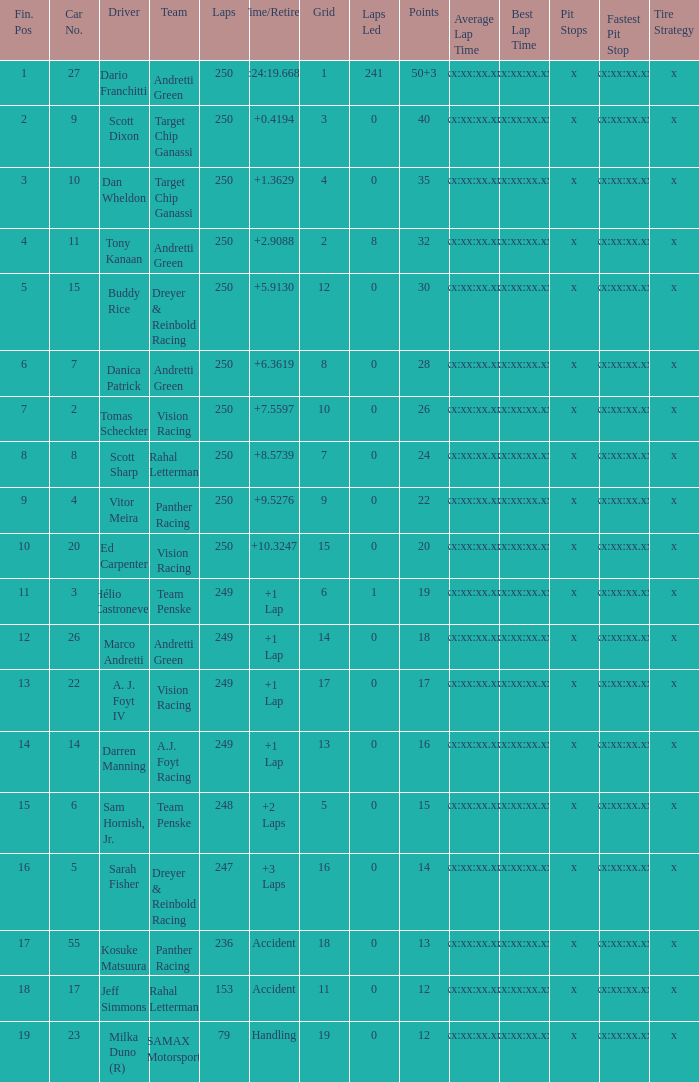Name the number of driver for fin pos of 19 1.0. 